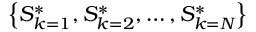Convert formula to latex. <formula><loc_0><loc_0><loc_500><loc_500>\left \{ S _ { k = 1 } ^ { * } , S _ { k = 2 } ^ { * } , \dots , S _ { k = N } ^ { * } \right \}</formula> 